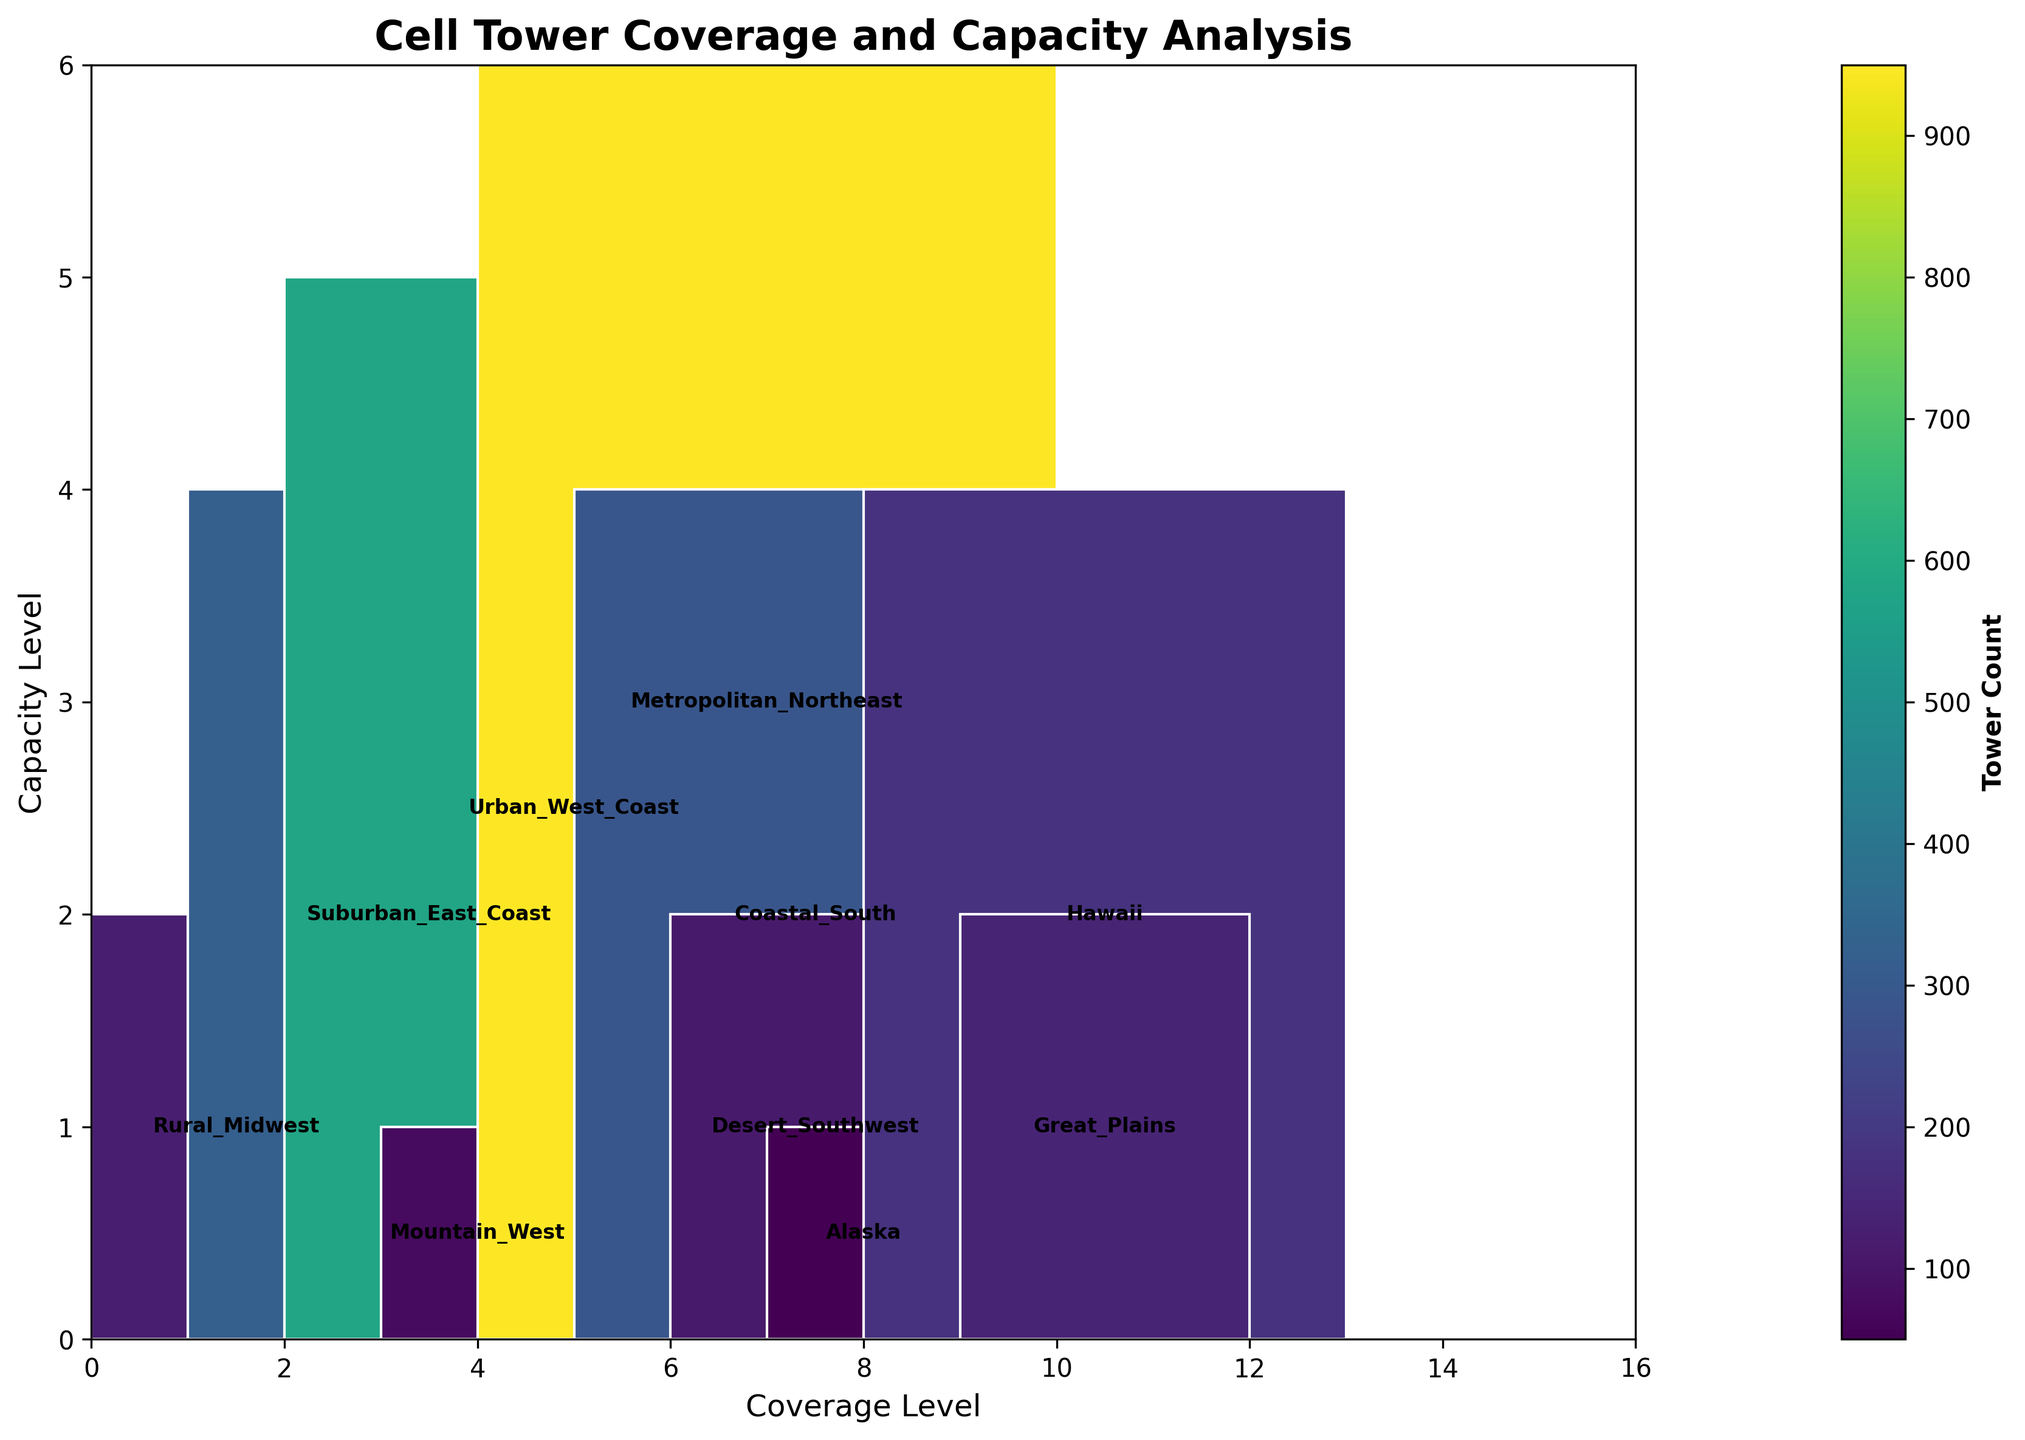What's the title of the plot? The title of the plot is usually placed at the top of the figure and it serves as an introduction to the visual data. In this case, the title "Cell Tower Coverage and Capacity Analysis" is clearly visible at the top of the plot.
Answer: Cell Tower Coverage and Capacity Analysis Which region has the highest coverage and capacity levels? To determine the highest coverage and capacity levels, locate the segment with the maximum height and width. "Metropolitan Northeast" has the highest values in both dimensions, as indicated by the largest rectangle in the plot.
Answer: Metropolitan Northeast How many regions have a "Medium" population density? Identify regions labeled with "Medium" population density. According to the data, "Suburban East Coast," "Coastal South," and "Hawaii" have medium population density, visualized on the plot with the same pattern.
Answer: 3 Which region has the smallest tower count? Each rectangle color in the plot represents the tower count, where lighter colors indicate smaller counts. The "Alaska" region is the lightest, indicating it has the smallest tower count.
Answer: Alaska Compare the tower counts for "Urban West Coast" and "Great Plains". Which has more towers? Check the color intensity for both regions, as deeper colors indicate a higher tower count. The "Urban West Coast" blocks are darker and larger than "Great Plains," indicating a higher tower number for "Urban West Coast".
Answer: Urban West Coast What is the relationship between population density and coverage level for "Rural Midwest"? The "Rural Midwest" region has a low population density and a moderate coverage level, represented by its moderate width in the plot.
Answer: Low population density, Moderate coverage level How does the capacity level in "Mountain West" compare to that in "Suburban East Coast"? By examining the height of the rectangles, the "Mountain West" has a very low capacity level (shorter height), while the "Suburban East Coast" has a medium capacity level (taller height).
Answer: Mountain West has very low, Suburban East Coast has medium What's the color gradient representing in the plot? The color gradient ranges from light to dark, reflecting the tower count where lighter colors signify fewer towers and darker colors indicate more towers. This helps in quickly assessing regions with differing tower densities.
Answer: Tower count Which region stands out due to very high values in both coverage and capacity levels? Noticing the largest rectangle in both dimensions highlights "Metropolitan Northeast," which has very high levels in both coverage and capacity, evident from the width and height.
Answer: Metropolitan Northeast 